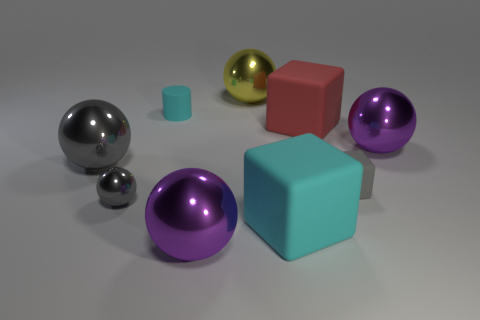What number of big yellow spheres have the same material as the gray cube?
Offer a very short reply. 0. There is a purple metallic thing that is right of the cyan rubber cube; does it have the same size as the yellow metallic object?
Your answer should be compact. Yes. The matte cylinder that is the same size as the gray cube is what color?
Your response must be concise. Cyan. There is a gray block; what number of big red blocks are behind it?
Offer a terse response. 1. Is there a big purple metallic ball?
Offer a terse response. Yes. There is a purple object in front of the large purple object that is to the right of the metallic object that is behind the red block; what is its size?
Give a very brief answer. Large. How many other objects are the same size as the yellow shiny sphere?
Make the answer very short. 5. What size is the metal thing behind the cylinder?
Your answer should be very brief. Large. Is there anything else of the same color as the tiny rubber cube?
Give a very brief answer. Yes. Do the purple ball behind the large gray ball and the cyan cube have the same material?
Your answer should be compact. No. 